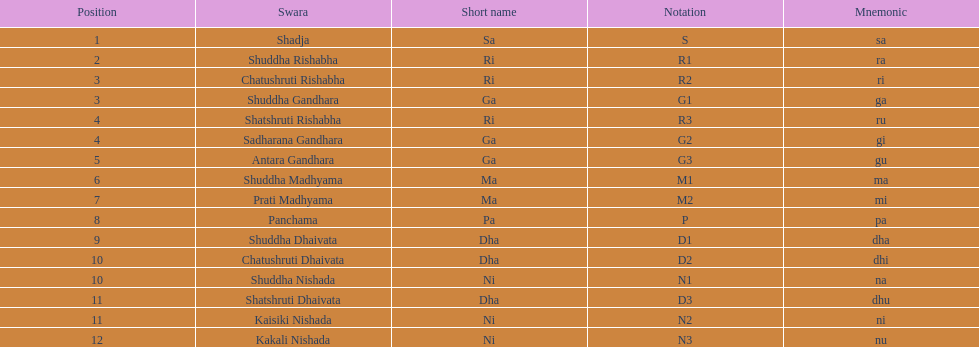Other than m1 how many notations have "1" in them? 4. Parse the full table. {'header': ['Position', 'Swara', 'Short name', 'Notation', 'Mnemonic'], 'rows': [['1', 'Shadja', 'Sa', 'S', 'sa'], ['2', 'Shuddha Rishabha', 'Ri', 'R1', 'ra'], ['3', 'Chatushruti Rishabha', 'Ri', 'R2', 'ri'], ['3', 'Shuddha Gandhara', 'Ga', 'G1', 'ga'], ['4', 'Shatshruti Rishabha', 'Ri', 'R3', 'ru'], ['4', 'Sadharana Gandhara', 'Ga', 'G2', 'gi'], ['5', 'Antara Gandhara', 'Ga', 'G3', 'gu'], ['6', 'Shuddha Madhyama', 'Ma', 'M1', 'ma'], ['7', 'Prati Madhyama', 'Ma', 'M2', 'mi'], ['8', 'Panchama', 'Pa', 'P', 'pa'], ['9', 'Shuddha Dhaivata', 'Dha', 'D1', 'dha'], ['10', 'Chatushruti Dhaivata', 'Dha', 'D2', 'dhi'], ['10', 'Shuddha Nishada', 'Ni', 'N1', 'na'], ['11', 'Shatshruti Dhaivata', 'Dha', 'D3', 'dhu'], ['11', 'Kaisiki Nishada', 'Ni', 'N2', 'ni'], ['12', 'Kakali Nishada', 'Ni', 'N3', 'nu']]} 